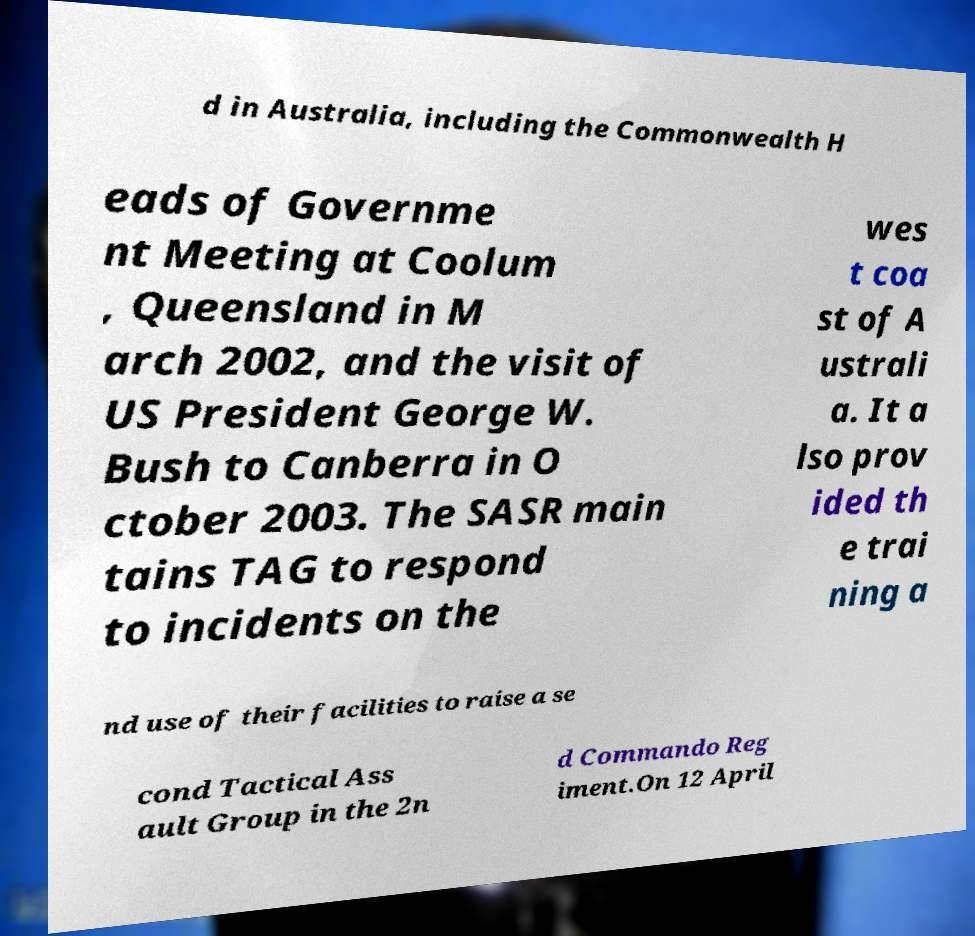I need the written content from this picture converted into text. Can you do that? d in Australia, including the Commonwealth H eads of Governme nt Meeting at Coolum , Queensland in M arch 2002, and the visit of US President George W. Bush to Canberra in O ctober 2003. The SASR main tains TAG to respond to incidents on the wes t coa st of A ustrali a. It a lso prov ided th e trai ning a nd use of their facilities to raise a se cond Tactical Ass ault Group in the 2n d Commando Reg iment.On 12 April 